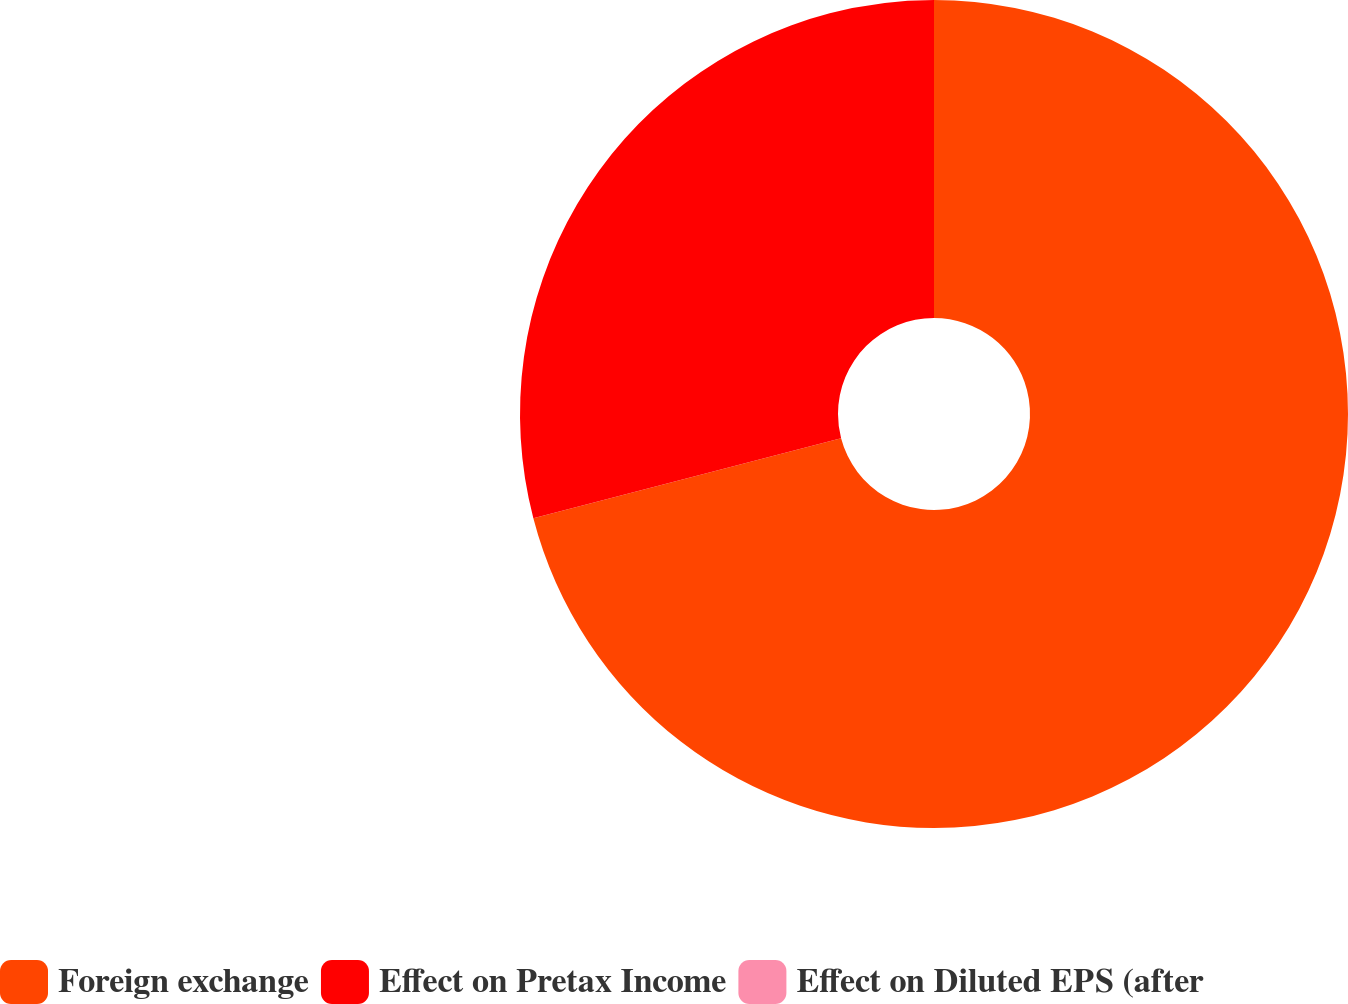<chart> <loc_0><loc_0><loc_500><loc_500><pie_chart><fcel>Foreign exchange<fcel>Effect on Pretax Income<fcel>Effect on Diluted EPS (after<nl><fcel>70.94%<fcel>29.05%<fcel>0.0%<nl></chart> 